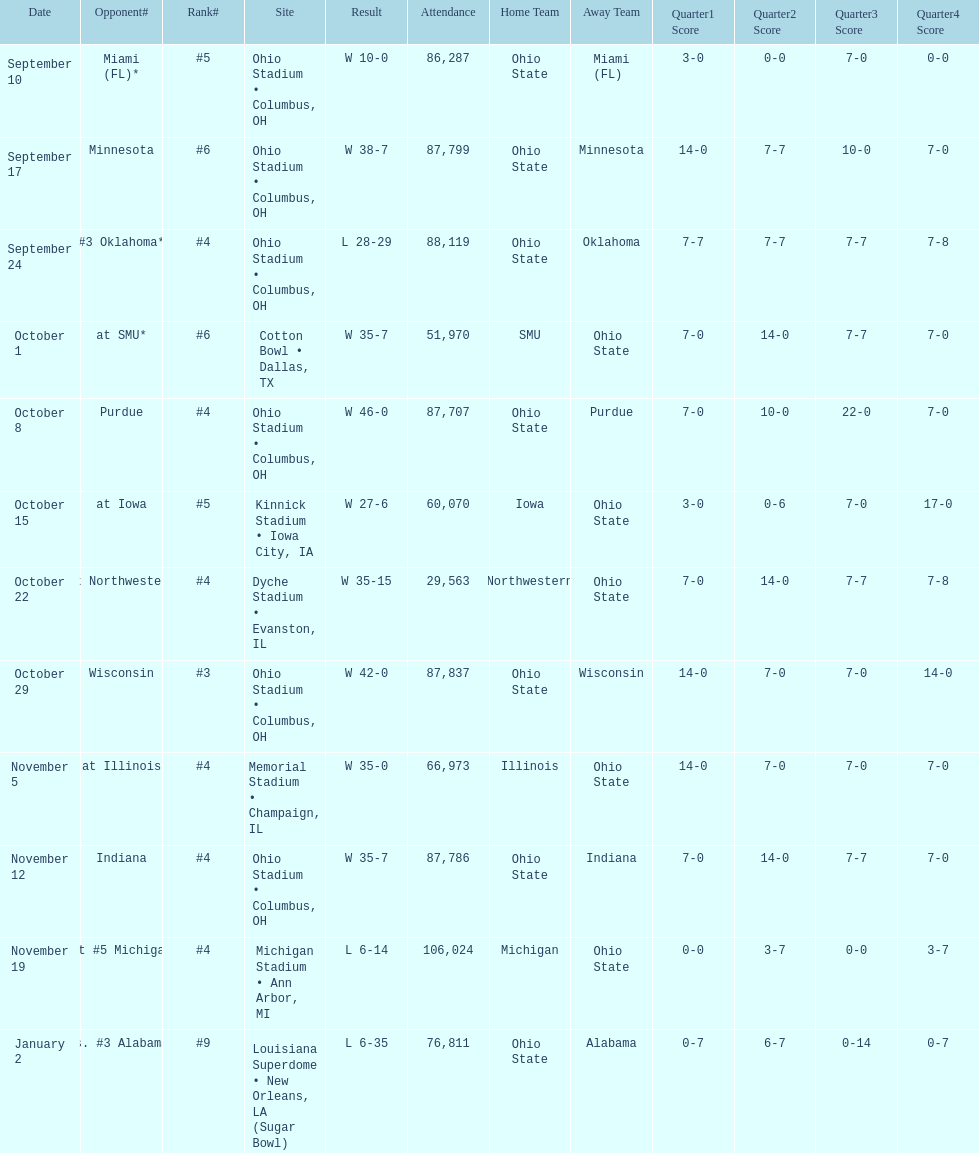What was the last game to be attended by fewer than 30,000 people? October 22. 